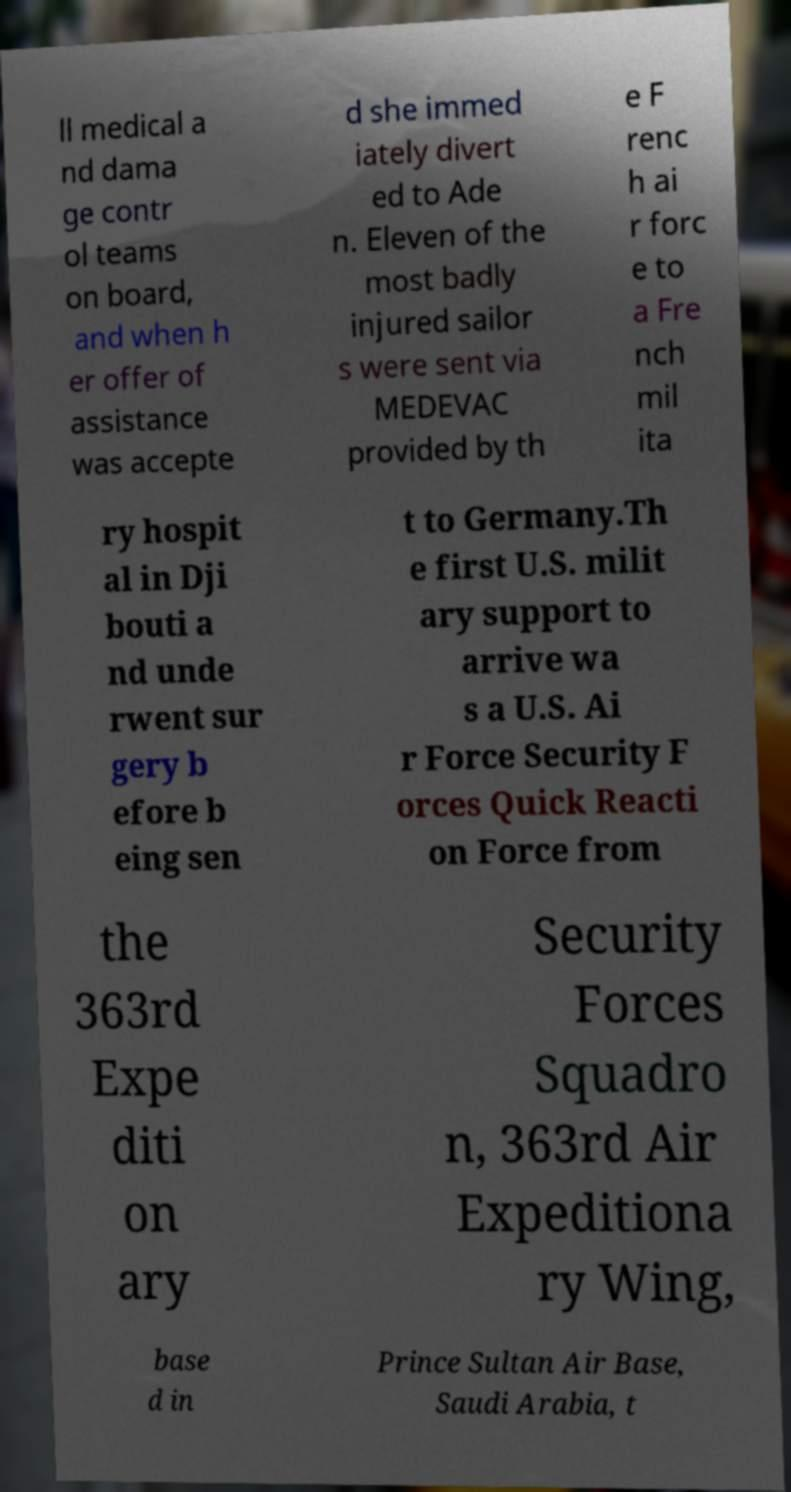Could you assist in decoding the text presented in this image and type it out clearly? ll medical a nd dama ge contr ol teams on board, and when h er offer of assistance was accepte d she immed iately divert ed to Ade n. Eleven of the most badly injured sailor s were sent via MEDEVAC provided by th e F renc h ai r forc e to a Fre nch mil ita ry hospit al in Dji bouti a nd unde rwent sur gery b efore b eing sen t to Germany.Th e first U.S. milit ary support to arrive wa s a U.S. Ai r Force Security F orces Quick Reacti on Force from the 363rd Expe diti on ary Security Forces Squadro n, 363rd Air Expeditiona ry Wing, base d in Prince Sultan Air Base, Saudi Arabia, t 